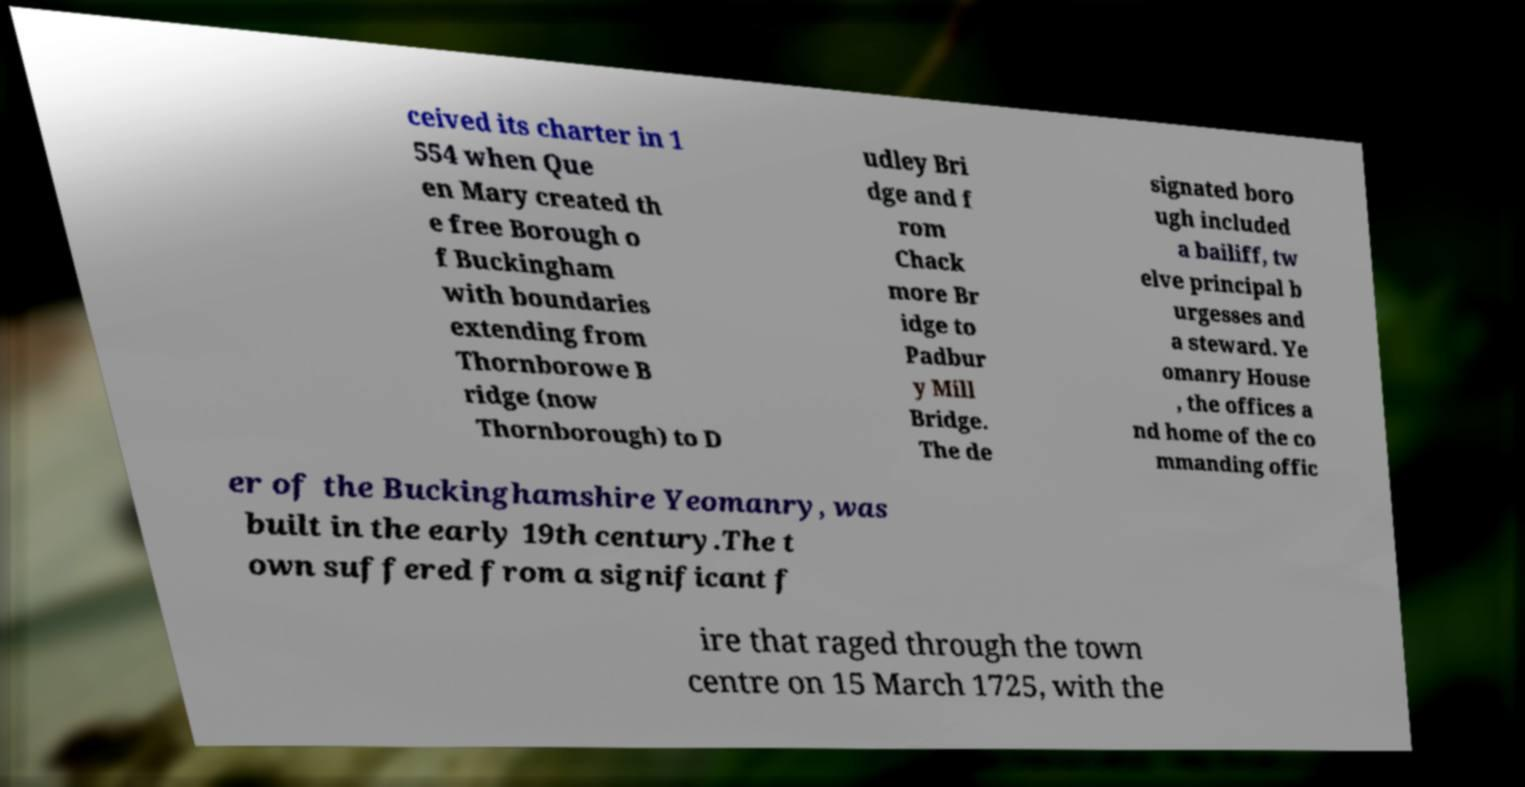I need the written content from this picture converted into text. Can you do that? ceived its charter in 1 554 when Que en Mary created th e free Borough o f Buckingham with boundaries extending from Thornborowe B ridge (now Thornborough) to D udley Bri dge and f rom Chack more Br idge to Padbur y Mill Bridge. The de signated boro ugh included a bailiff, tw elve principal b urgesses and a steward. Ye omanry House , the offices a nd home of the co mmanding offic er of the Buckinghamshire Yeomanry, was built in the early 19th century.The t own suffered from a significant f ire that raged through the town centre on 15 March 1725, with the 